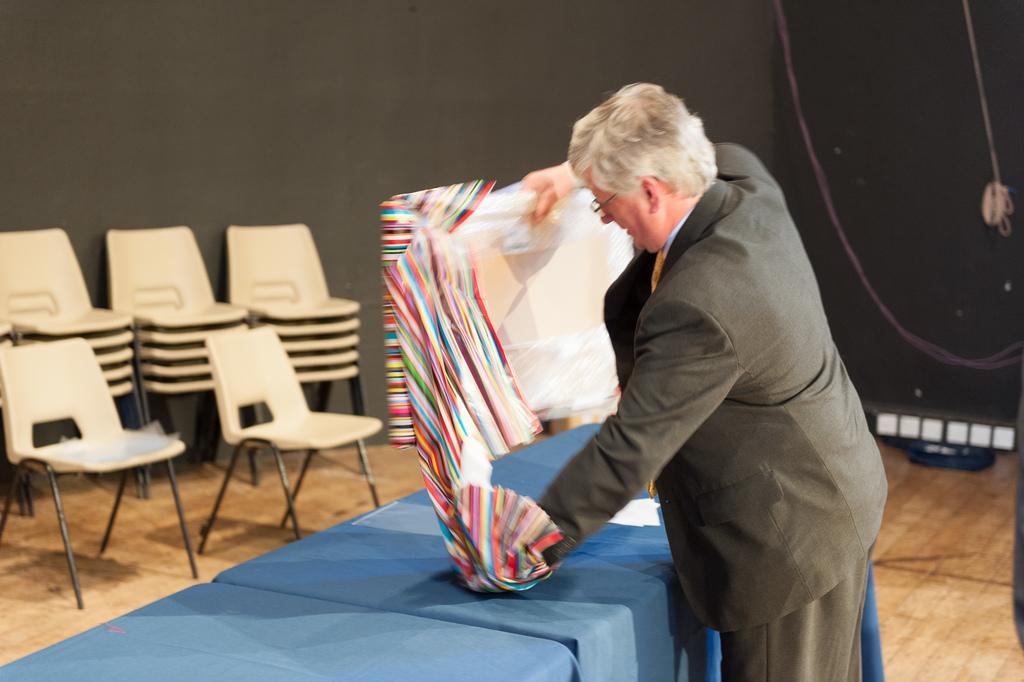How would you summarize this image in a sentence or two? Here we can see few empty chairs at the left side of the picture. This is a floor. Here we can see a man wearing a blazer holding a frame in his hand and he is opening the cover of a frame. He wore spectacles. 